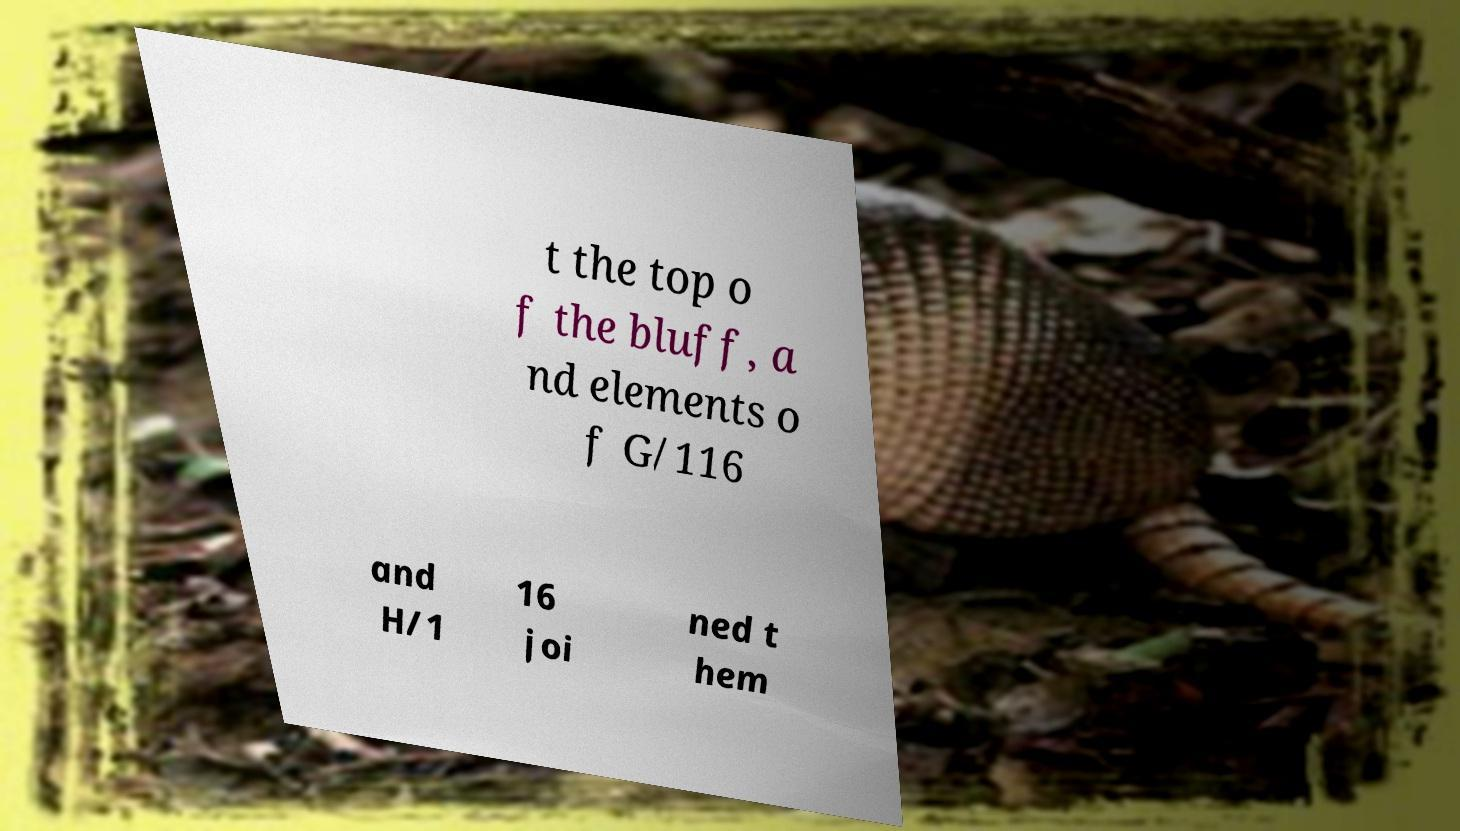There's text embedded in this image that I need extracted. Can you transcribe it verbatim? t the top o f the bluff, a nd elements o f G/116 and H/1 16 joi ned t hem 